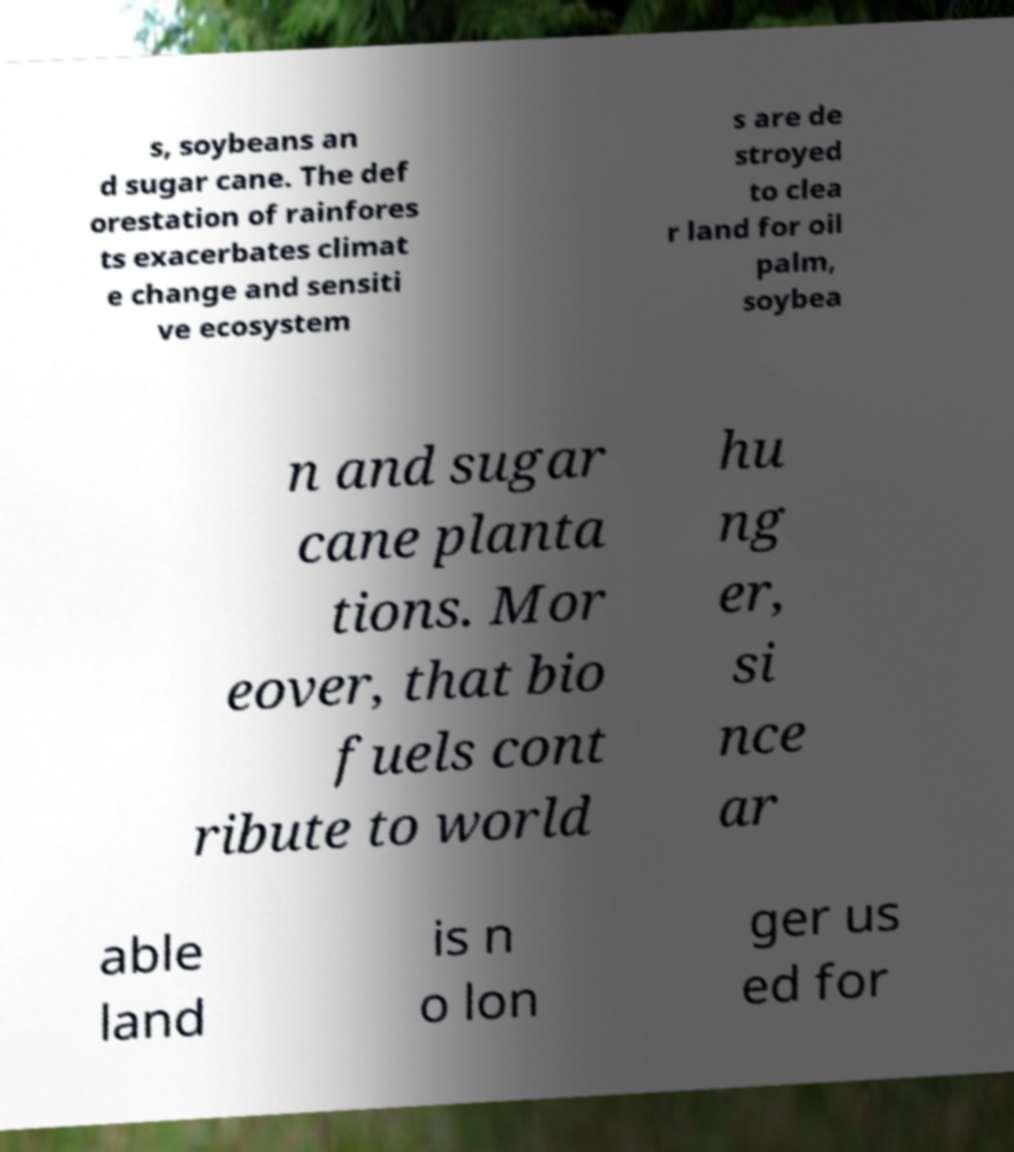Can you accurately transcribe the text from the provided image for me? s, soybeans an d sugar cane. The def orestation of rainfores ts exacerbates climat e change and sensiti ve ecosystem s are de stroyed to clea r land for oil palm, soybea n and sugar cane planta tions. Mor eover, that bio fuels cont ribute to world hu ng er, si nce ar able land is n o lon ger us ed for 